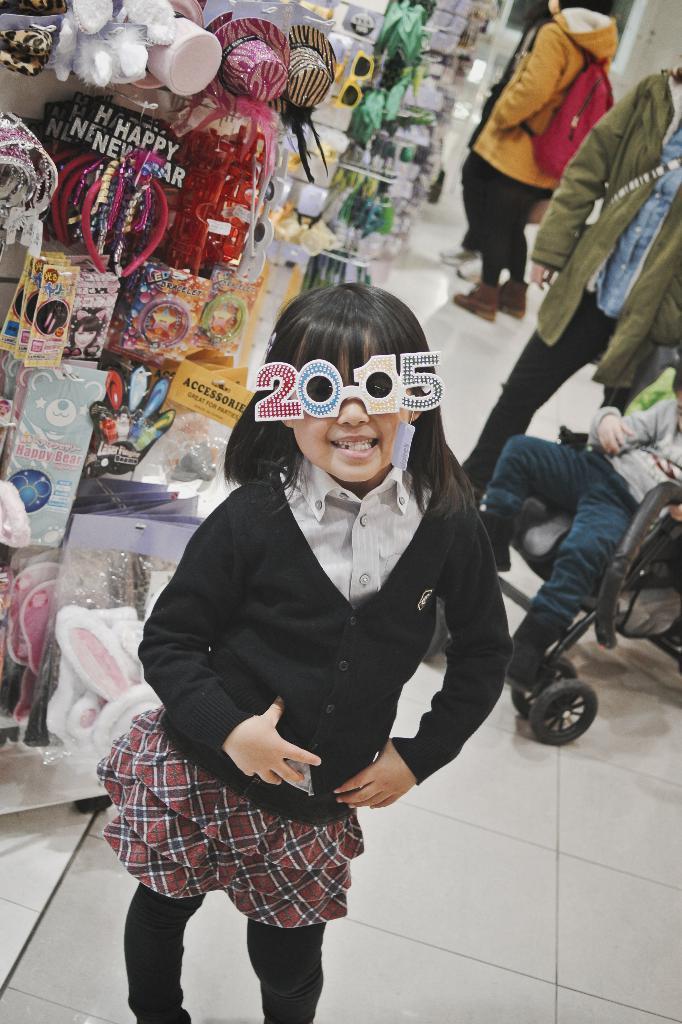Can you describe this image briefly? In this picture I can see there is a kid standing and wearing spectacles and a black coat and a skirt and in the backdrop there are few other people standing and there are few hair bands and few other items on to left. 